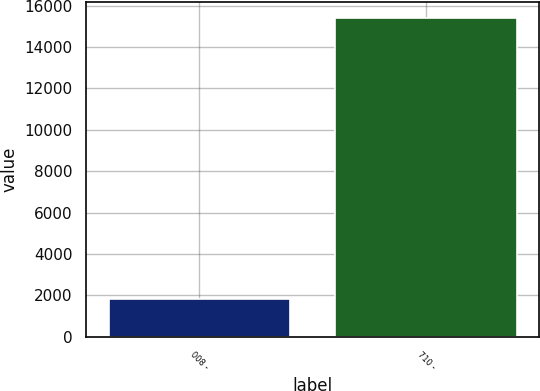<chart> <loc_0><loc_0><loc_500><loc_500><bar_chart><fcel>008 -<fcel>710 -<nl><fcel>1843<fcel>15400<nl></chart> 